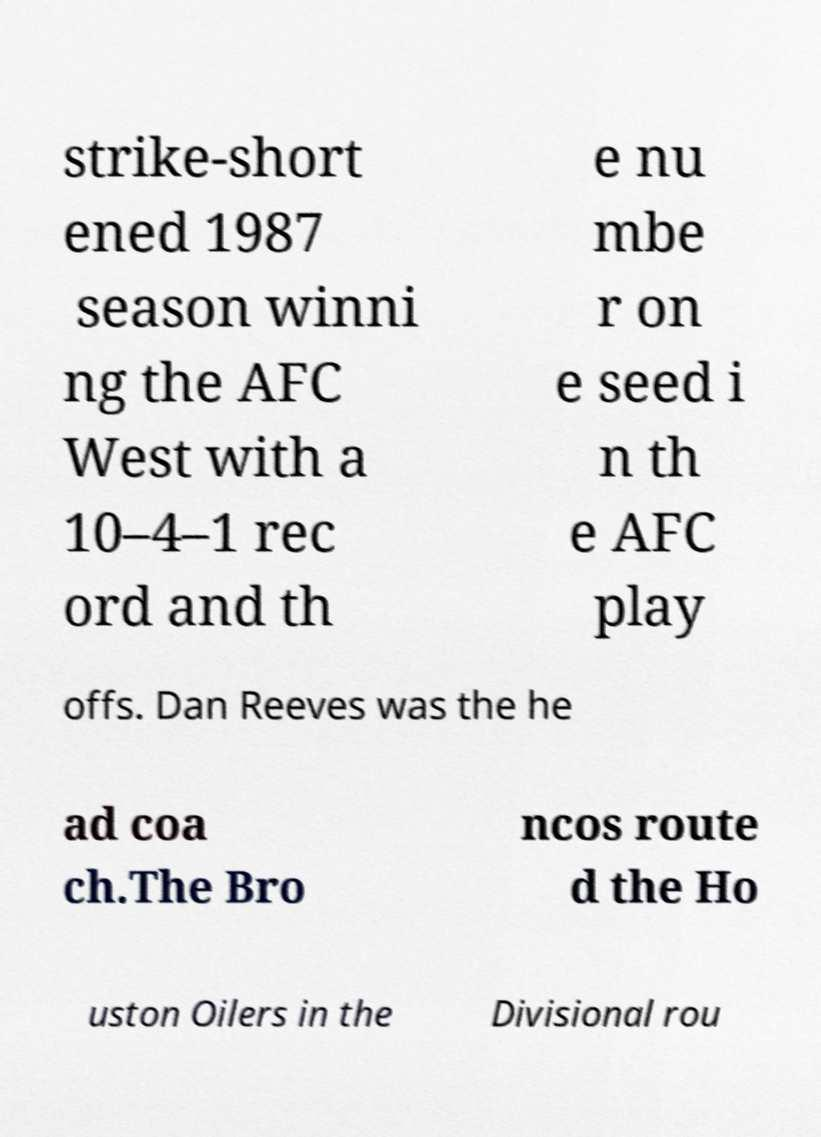Can you read and provide the text displayed in the image?This photo seems to have some interesting text. Can you extract and type it out for me? strike-short ened 1987 season winni ng the AFC West with a 10–4–1 rec ord and th e nu mbe r on e seed i n th e AFC play offs. Dan Reeves was the he ad coa ch.The Bro ncos route d the Ho uston Oilers in the Divisional rou 